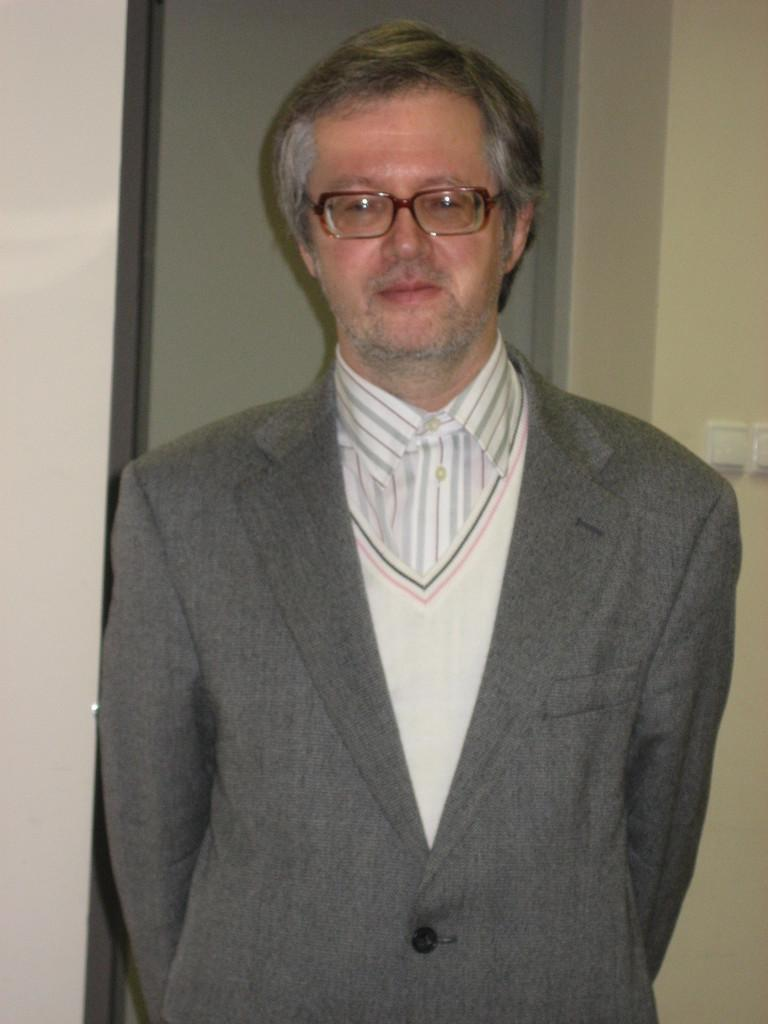What is the main subject of the image? There is a person standing in the image. What is the person wearing? The person is wearing a dress. Can you describe the colors of the dress? The dress has ash, white, and pink colors. What can be seen in the background of the image? There are switches on the wall in the background of the image. What type of cabbage is being grown in the country shown in the image? There is no country or cabbage present in the image; it features a person wearing a dress with switches on the wall in the background. 